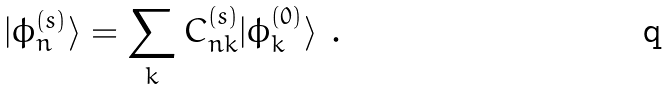Convert formula to latex. <formula><loc_0><loc_0><loc_500><loc_500>| \phi _ { n } ^ { ( s ) } \rangle = \sum _ { k } C _ { n k } ^ { ( s ) } | \phi _ { k } ^ { ( 0 ) } \rangle \ .</formula> 